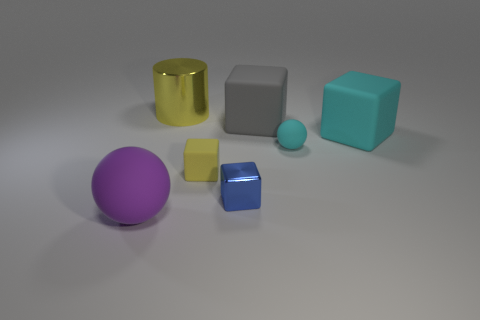How many purple objects are the same material as the large gray block?
Offer a very short reply. 1. What is the size of the ball that is to the right of the large rubber thing that is on the left side of the tiny shiny block in front of the gray matte thing?
Make the answer very short. Small. There is a big cyan rubber object; how many big yellow cylinders are left of it?
Offer a terse response. 1. Is the number of large blue rubber cylinders greater than the number of cyan matte things?
Offer a terse response. No. There is a cube that is the same color as the tiny sphere; what size is it?
Ensure brevity in your answer.  Large. How big is the matte cube that is both in front of the big gray object and on the right side of the blue shiny block?
Ensure brevity in your answer.  Large. There is a sphere that is on the right side of the big thing that is on the left side of the yellow object behind the small cyan matte thing; what is it made of?
Give a very brief answer. Rubber. There is a thing that is the same color as the cylinder; what is it made of?
Your answer should be compact. Rubber. Is the color of the metallic object on the left side of the small yellow matte thing the same as the sphere on the right side of the purple matte object?
Provide a succinct answer. No. What is the shape of the shiny thing in front of the shiny thing that is behind the rubber sphere that is on the right side of the purple rubber sphere?
Your answer should be very brief. Cube. 